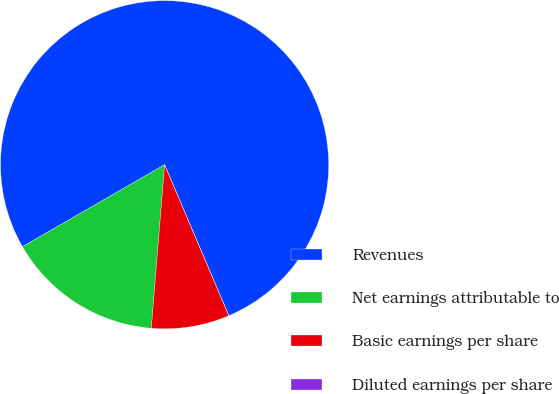Convert chart. <chart><loc_0><loc_0><loc_500><loc_500><pie_chart><fcel>Revenues<fcel>Net earnings attributable to<fcel>Basic earnings per share<fcel>Diluted earnings per share<nl><fcel>76.92%<fcel>15.38%<fcel>7.69%<fcel>0.0%<nl></chart> 